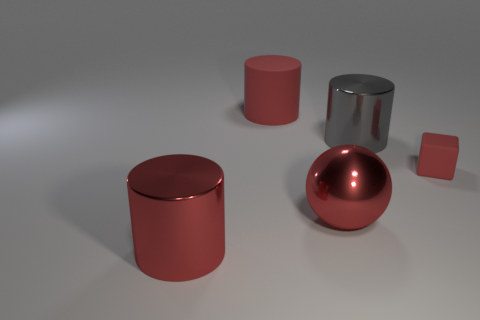Subtract all red cylinders. How many cylinders are left? 1 Subtract all red cylinders. How many cylinders are left? 1 Subtract all spheres. How many objects are left? 4 Subtract 1 cylinders. How many cylinders are left? 2 Subtract all gray spheres. How many gray cylinders are left? 1 Add 2 tiny matte balls. How many objects exist? 7 Subtract all blue spheres. Subtract all red cylinders. How many spheres are left? 1 Subtract all large brown metallic cubes. Subtract all large red metal things. How many objects are left? 3 Add 3 red shiny things. How many red shiny things are left? 5 Add 1 red cubes. How many red cubes exist? 2 